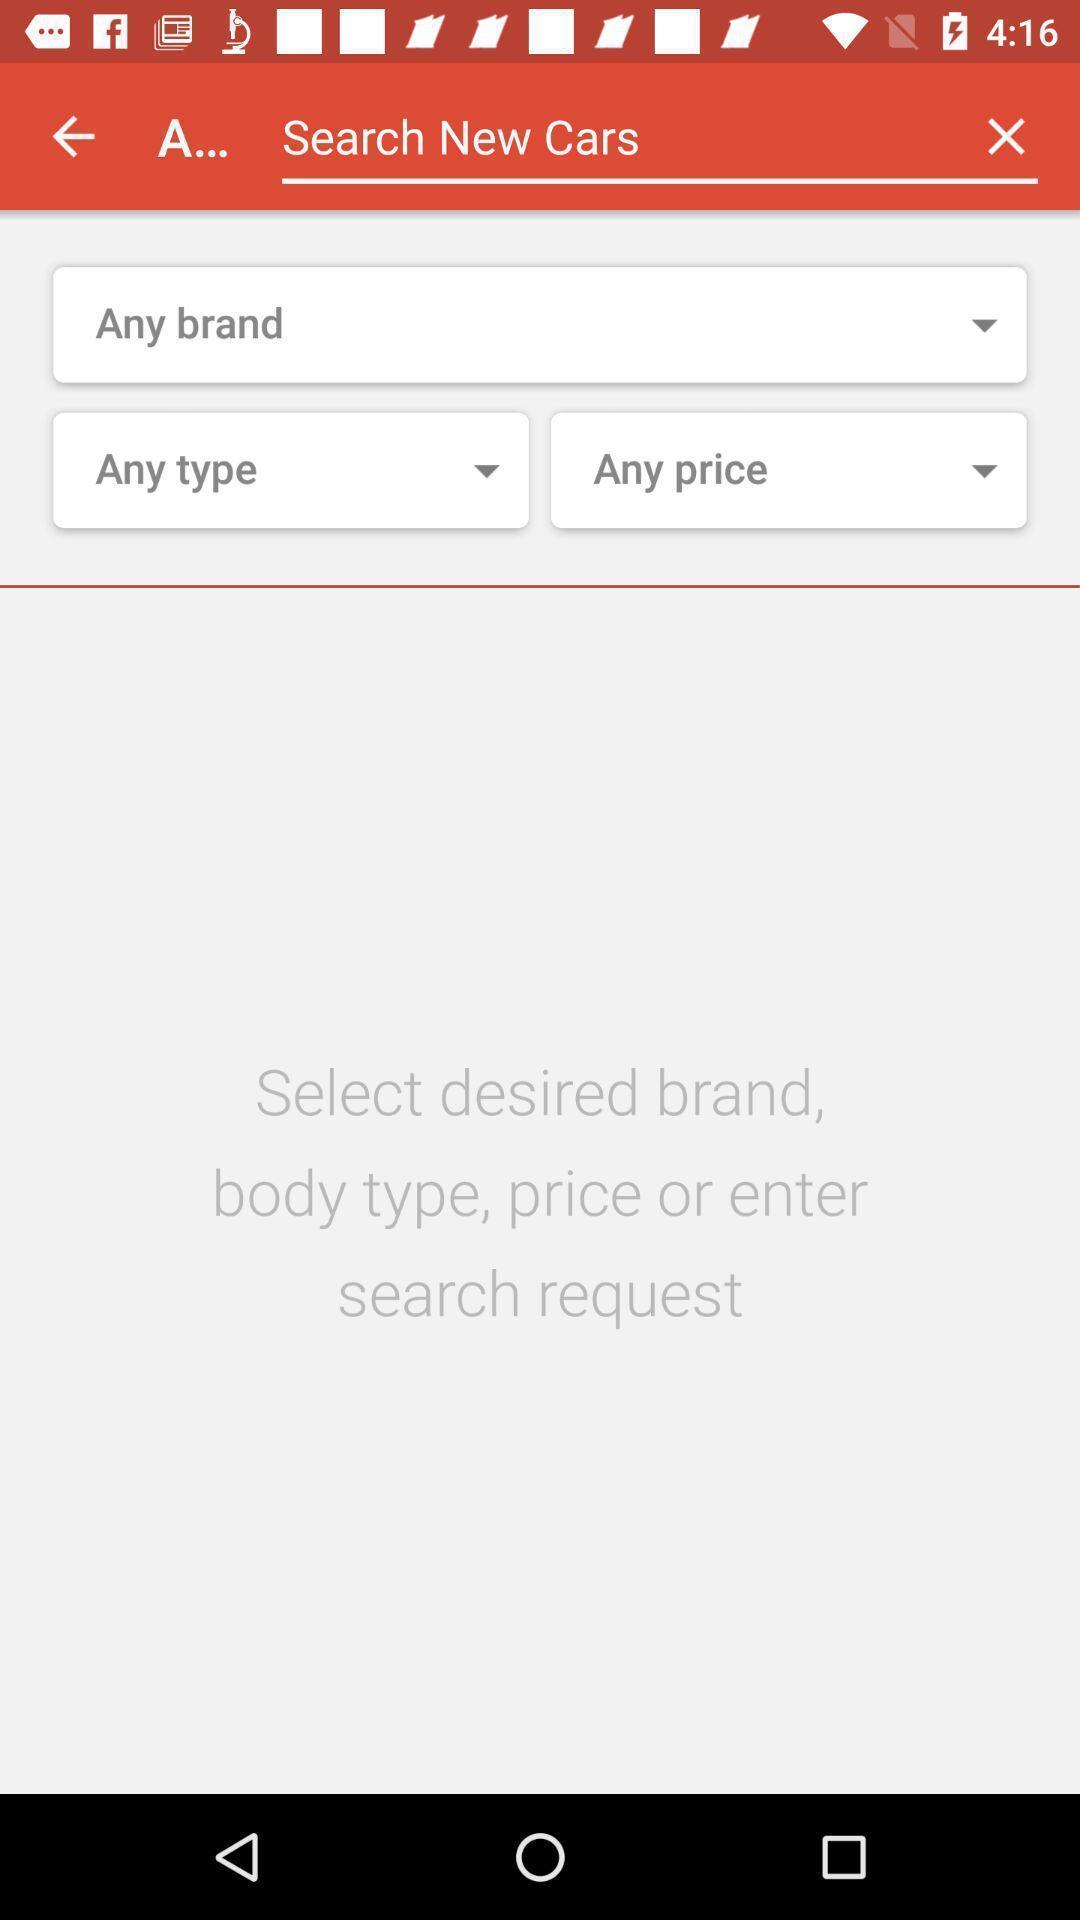Describe the visual elements of this screenshot. Search box displaying in this page. 